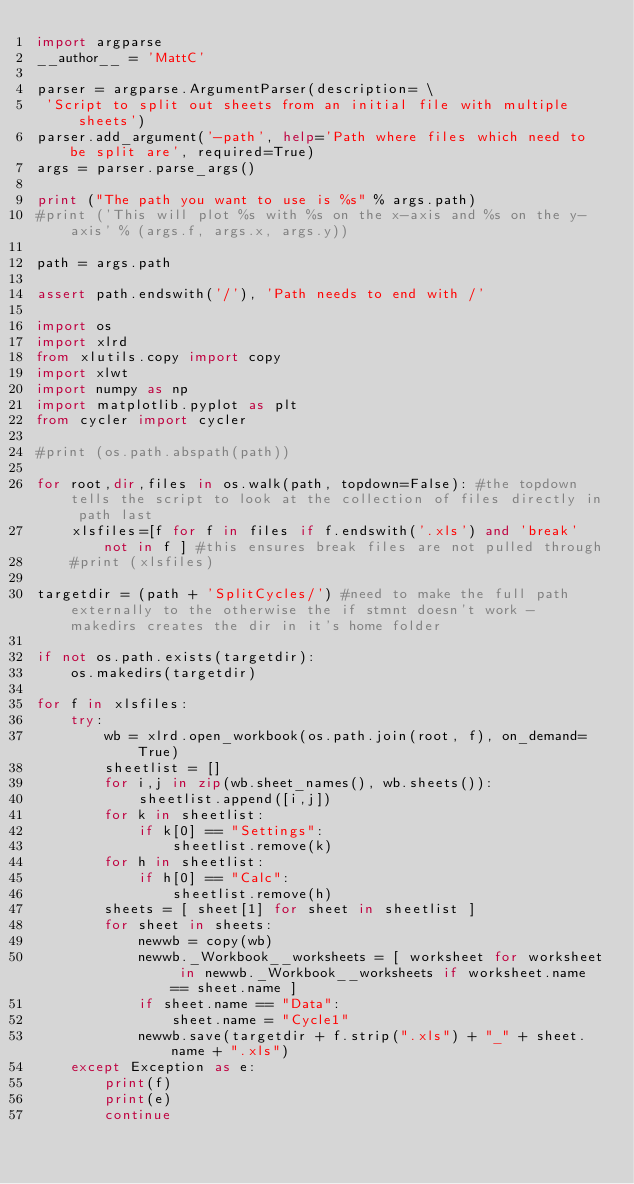Convert code to text. <code><loc_0><loc_0><loc_500><loc_500><_Python_>import argparse
__author__ = 'MattC'

parser = argparse.ArgumentParser(description= \
 'Script to split out sheets from an initial file with multiple sheets')
parser.add_argument('-path', help='Path where files which need to be split are', required=True)
args = parser.parse_args()

print ("The path you want to use is %s" % args.path)
#print ('This will plot %s with %s on the x-axis and %s on the y-axis' % (args.f, args.x, args.y))

path = args.path

assert path.endswith('/'), 'Path needs to end with /'

import os
import xlrd
from xlutils.copy import copy
import xlwt
import numpy as np
import matplotlib.pyplot as plt
from cycler import cycler

#print (os.path.abspath(path))

for root,dir,files in os.walk(path, topdown=False): #the topdown tells the script to look at the collection of files directly in path last
    xlsfiles=[f for f in files if f.endswith('.xls') and 'break' not in f ] #this ensures break files are not pulled through
    #print (xlsfiles)

targetdir = (path + 'SplitCycles/') #need to make the full path externally to the otherwise the if stmnt doesn't work - makedirs creates the dir in it's home folder

if not os.path.exists(targetdir):
    os.makedirs(targetdir)

for f in xlsfiles:
    try:
        wb = xlrd.open_workbook(os.path.join(root, f), on_demand=True)
        sheetlist = []
        for i,j in zip(wb.sheet_names(), wb.sheets()):
            sheetlist.append([i,j])
        for k in sheetlist:
            if k[0] == "Settings":
                sheetlist.remove(k)
        for h in sheetlist:
            if h[0] == "Calc":
                sheetlist.remove(h)
        sheets = [ sheet[1] for sheet in sheetlist ]
        for sheet in sheets:
            newwb = copy(wb)
            newwb._Workbook__worksheets = [ worksheet for worksheet in newwb._Workbook__worksheets if worksheet.name == sheet.name ]
            if sheet.name == "Data":
                sheet.name = "Cycle1"
            newwb.save(targetdir + f.strip(".xls") + "_" + sheet.name + ".xls")
    except Exception as e:
        print(f)
        print(e)
        continue
</code> 